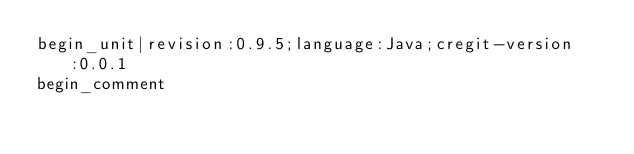Convert code to text. <code><loc_0><loc_0><loc_500><loc_500><_Java_>begin_unit|revision:0.9.5;language:Java;cregit-version:0.0.1
begin_comment</code> 